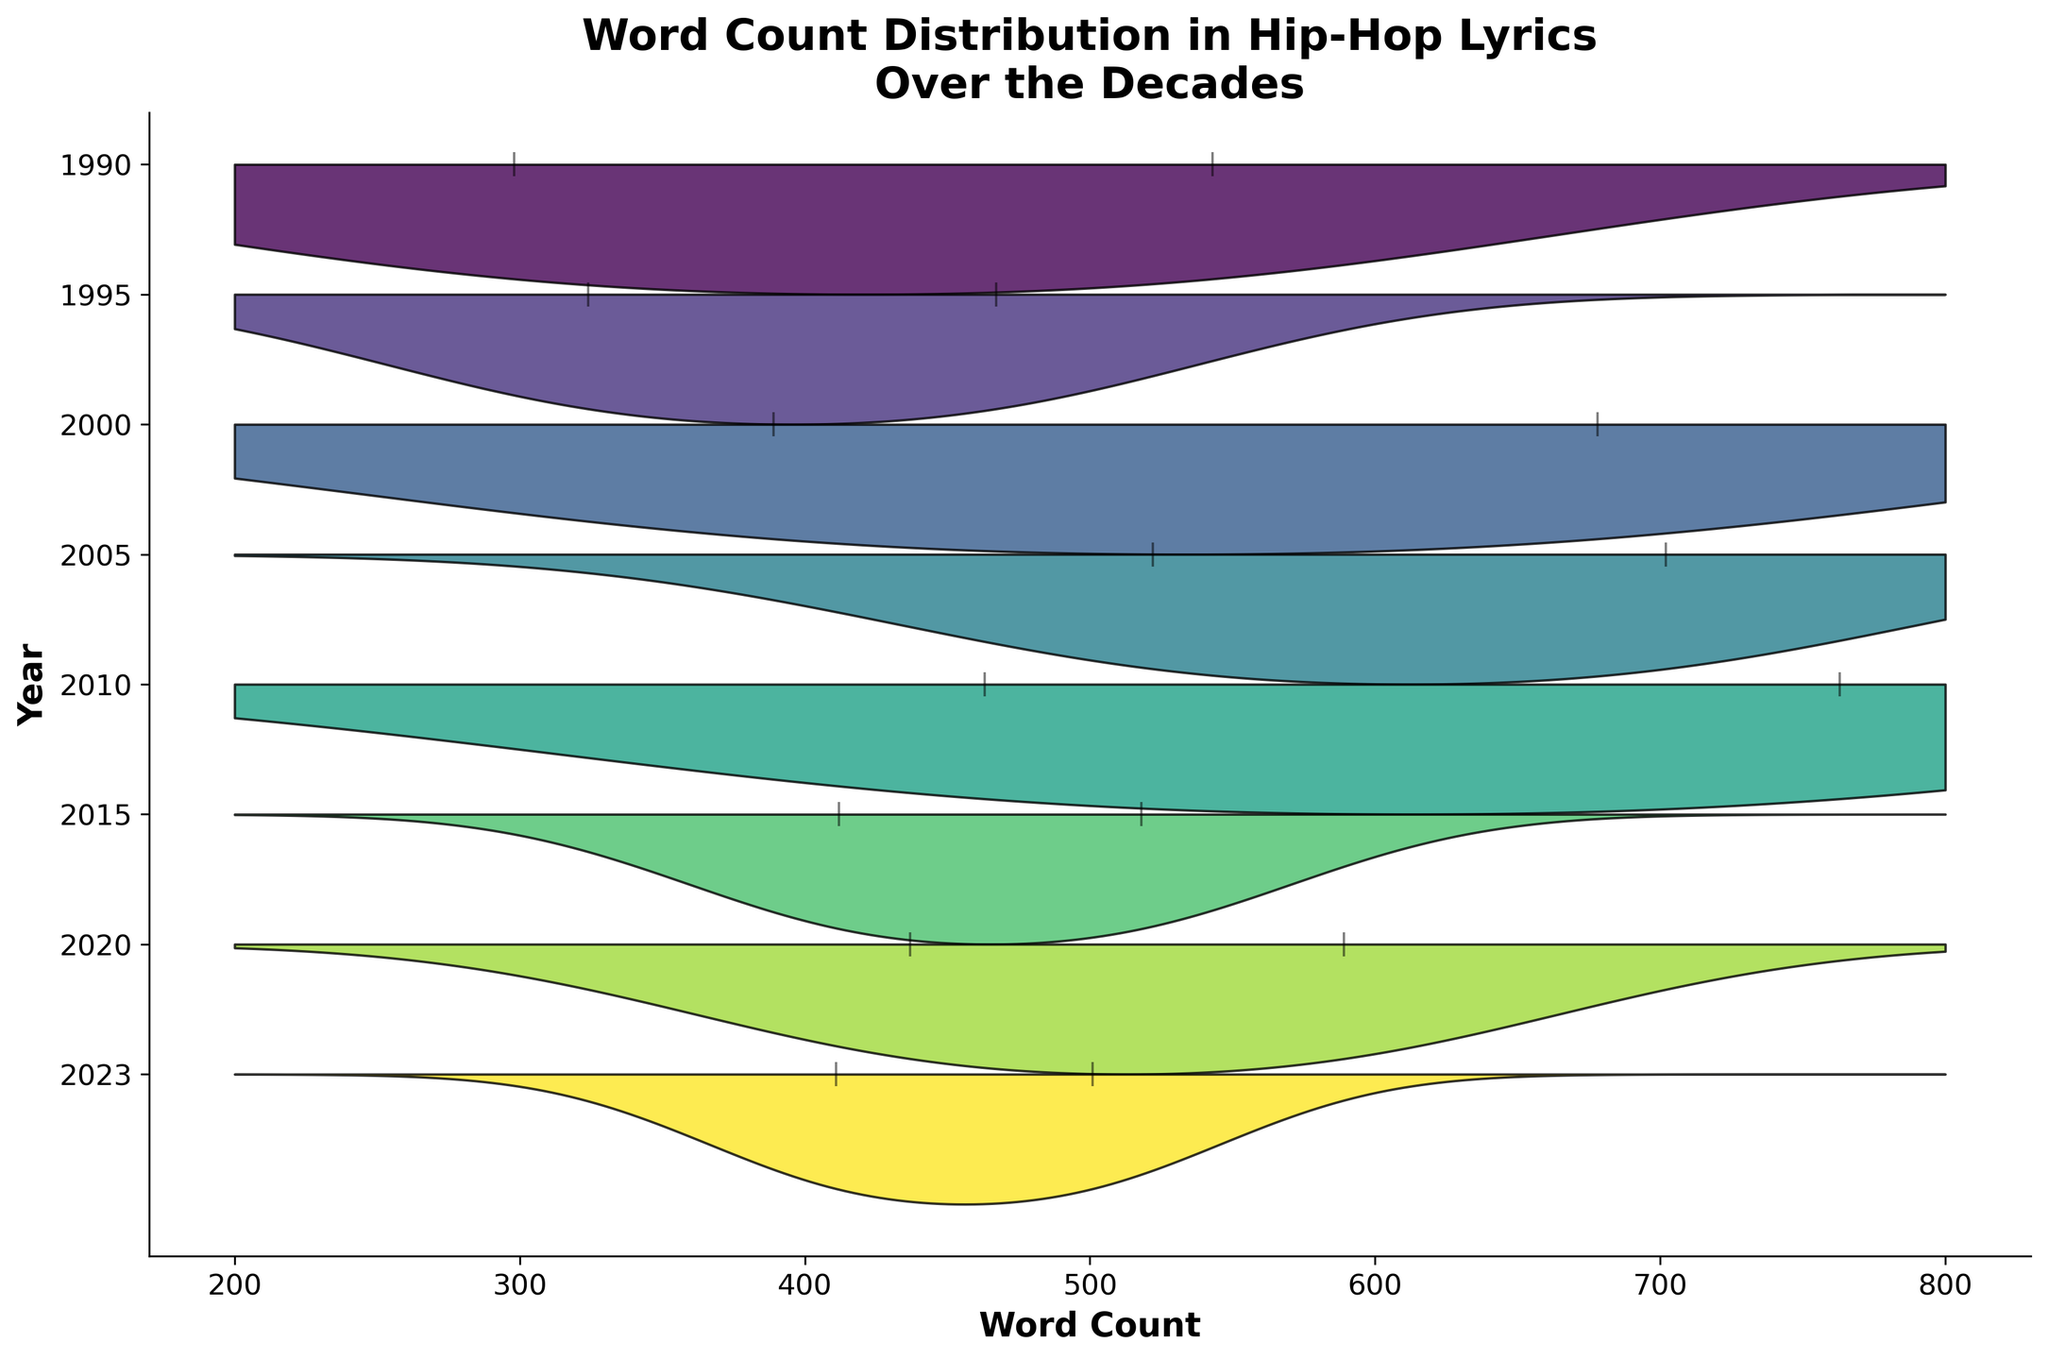what is the title of the ridgeline plot? The title is located at the top of the figure and provides an overview of what the plot represents.
Answer: Word Count Distribution in Hip-Hop Lyrics Over the Decades Which year has the highest word count density peak? Examining the ridgeline plot, look for the year with the peak that reaches the highest in terms of vertical position.
Answer: 2023 Are there more songs with a word count over 500 in 2000 or 2015? Compare the vertical lines plotted above 500 on the x-axis for the years 2000 and 2015.
Answer: 2000 What is the range of word counts for songs in 1990? Identify the spread of the density plot for 1990. It starts with the lowest value on the x-axis up to the highest value.
Answer: 298 to 543 Which year has the most uniform word count distribution? Look for the year with a flatter and more spread out density curve, indicating less variation and more uniformity.
Answer: 2010 Do more songs have word counts below or above 400 in 2023? Count the number of vertical lines (indicating data points) below 400 and those above 400 for the year 2023.
Answer: Above 400 How many peaks are present in the word count distribution for 2010? Count the number of distinct "hills" or peaks in the density plot for 2010.
Answer: 1 Which artist has the song with the highest word count? Locate the highest point on the x-axis among all vertical lines, then identify the artist for that data point.
Answer: Eminem How do the word counts in 2020 compare to those in 1990? Compare the density plots of 2020 and 1990, focusing on the shifts and shapes of the curves to determine overall differences.
Answer: Higher word counts in 2020 Between 2005 and 2020, which year shows a wider range of word counts in songs? Look at the spread or width of the density plots for both 2005 and 2020 to see which one covers a broader range on the x-axis.
Answer: 2020 